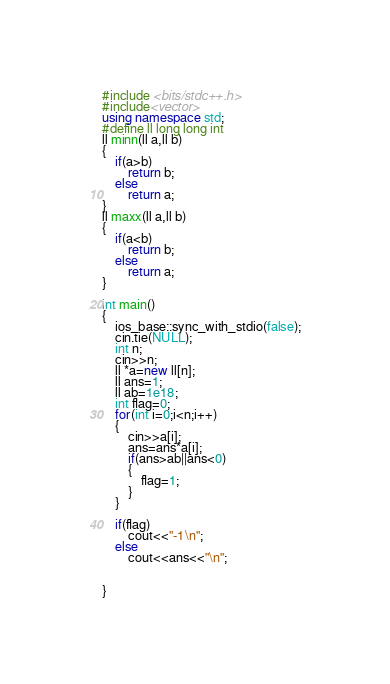<code> <loc_0><loc_0><loc_500><loc_500><_C++_>#include <bits/stdc++.h>
#include<vector>
using namespace std;
#define ll long long int
ll minn(ll a,ll b)
{
    if(a>b)
        return b;
    else
        return a;
}
ll maxx(ll a,ll b)
{
    if(a<b)
        return b;
    else
        return a;
}

int main()
{
    ios_base::sync_with_stdio(false);
    cin.tie(NULL);
    int n;
    cin>>n;
    ll *a=new ll[n];
    ll ans=1;
    ll ab=1e18;
    int flag=0;
    for(int i=0;i<n;i++)
    {
        cin>>a[i];
        ans=ans*a[i];
        if(ans>ab||ans<0)
        {
            flag=1;
        }
    }

    if(flag)
        cout<<"-1\n";
    else
        cout<<ans<<"\n";


}







</code> 